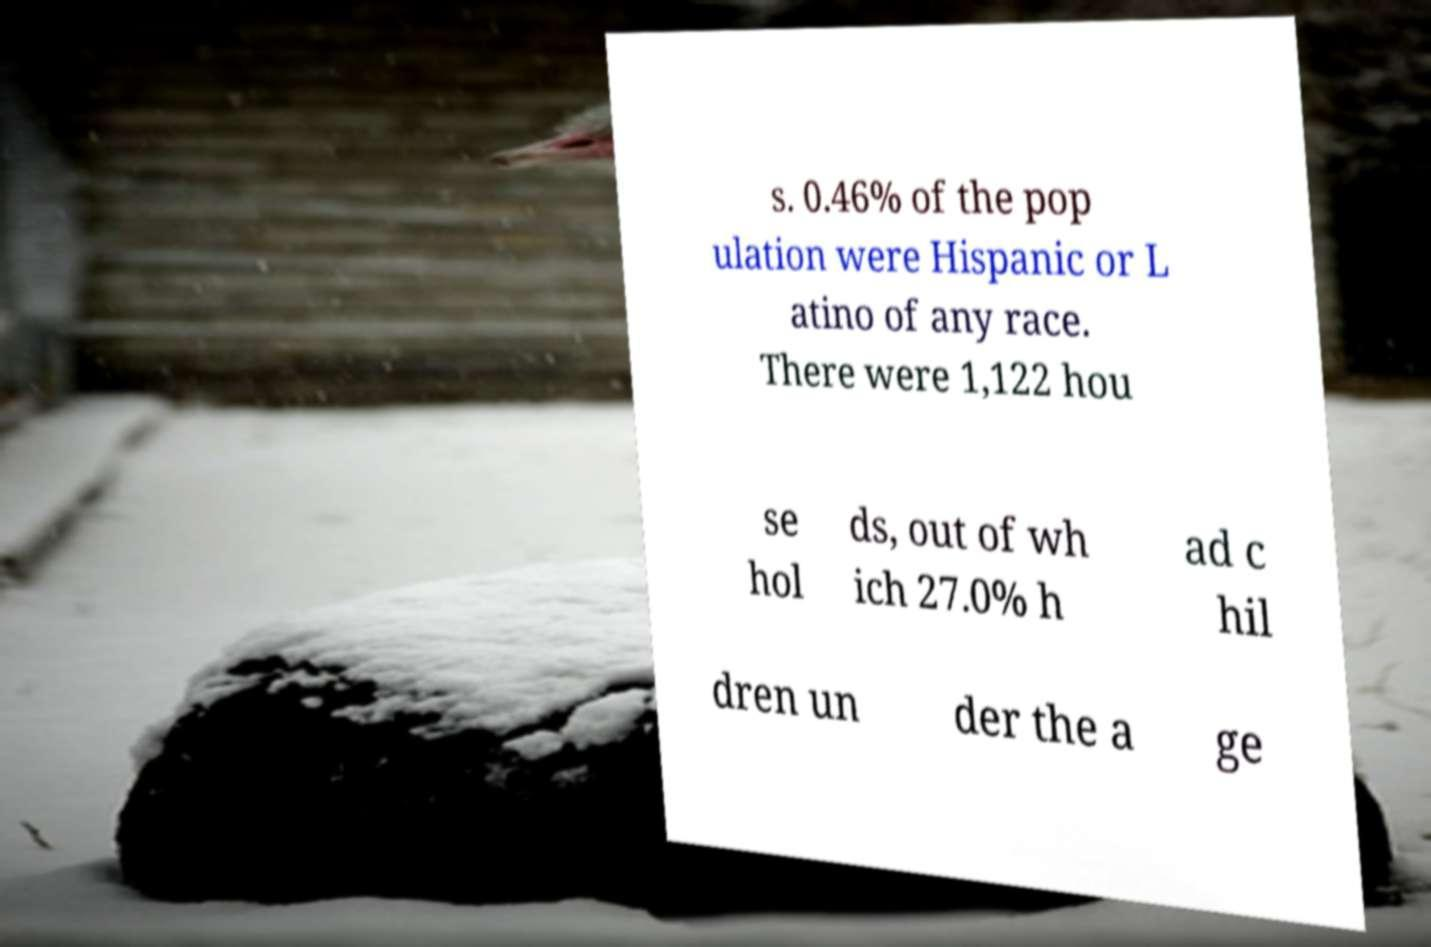Could you extract and type out the text from this image? s. 0.46% of the pop ulation were Hispanic or L atino of any race. There were 1,122 hou se hol ds, out of wh ich 27.0% h ad c hil dren un der the a ge 